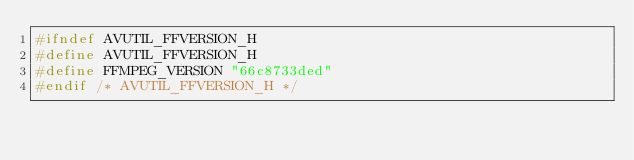<code> <loc_0><loc_0><loc_500><loc_500><_C_>#ifndef AVUTIL_FFVERSION_H
#define AVUTIL_FFVERSION_H
#define FFMPEG_VERSION "66c8733ded"
#endif /* AVUTIL_FFVERSION_H */
</code> 